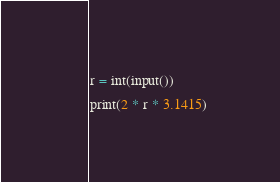<code> <loc_0><loc_0><loc_500><loc_500><_Python_>r = int(input())

print(2 * r * 3.1415)</code> 